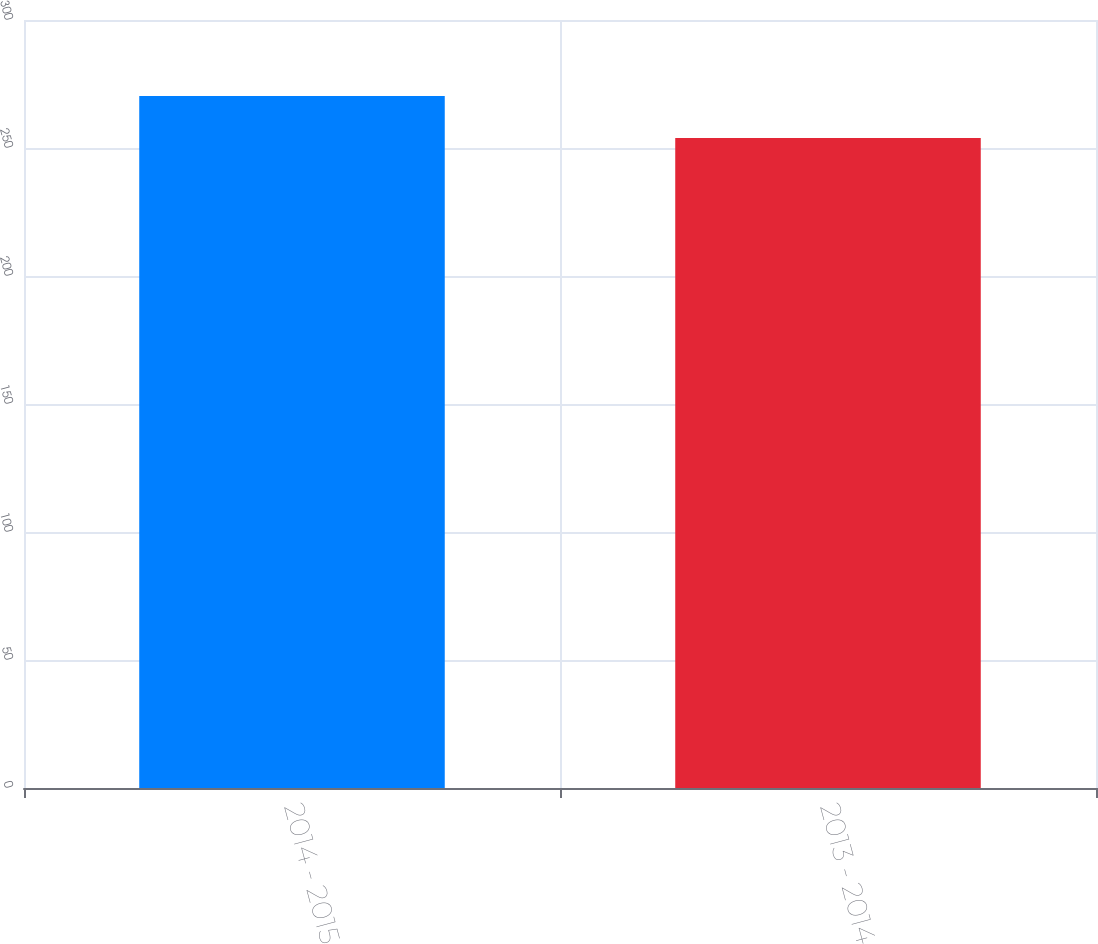Convert chart to OTSL. <chart><loc_0><loc_0><loc_500><loc_500><bar_chart><fcel>2014 - 2015<fcel>2013 - 2014<nl><fcel>270.3<fcel>253.9<nl></chart> 